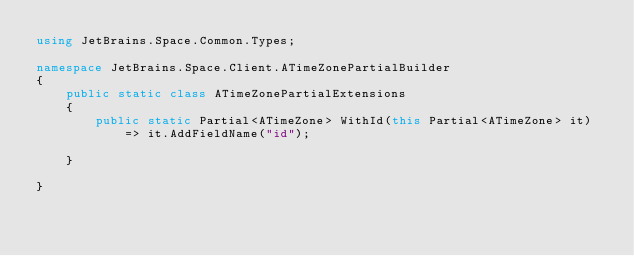Convert code to text. <code><loc_0><loc_0><loc_500><loc_500><_C#_>using JetBrains.Space.Common.Types;

namespace JetBrains.Space.Client.ATimeZonePartialBuilder
{
    public static class ATimeZonePartialExtensions
    {
        public static Partial<ATimeZone> WithId(this Partial<ATimeZone> it)
            => it.AddFieldName("id");
        
    }
    
}
</code> 